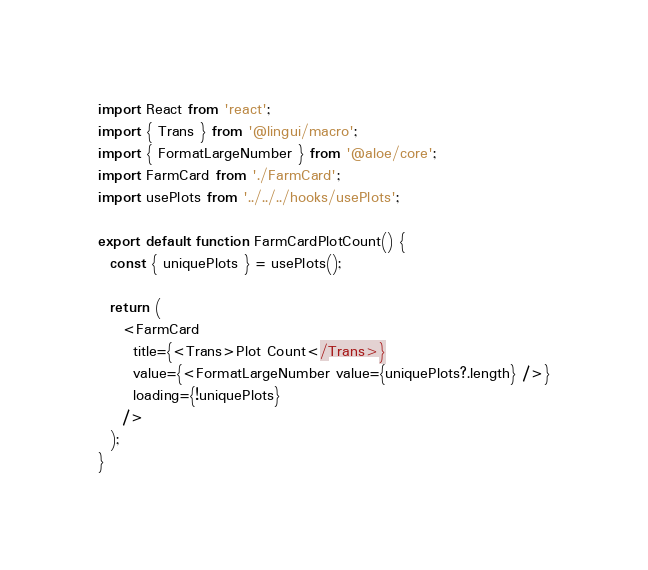Convert code to text. <code><loc_0><loc_0><loc_500><loc_500><_TypeScript_>import React from 'react';
import { Trans } from '@lingui/macro';
import { FormatLargeNumber } from '@aloe/core';
import FarmCard from './FarmCard';
import usePlots from '../../../hooks/usePlots';

export default function FarmCardPlotCount() {
  const { uniquePlots } = usePlots();

  return (
    <FarmCard
      title={<Trans>Plot Count</Trans>}
      value={<FormatLargeNumber value={uniquePlots?.length} />}
      loading={!uniquePlots}
    />
  );
}
</code> 